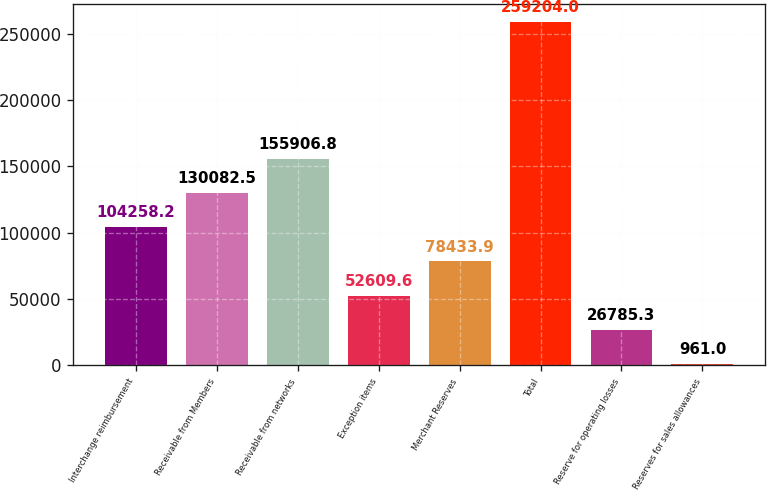<chart> <loc_0><loc_0><loc_500><loc_500><bar_chart><fcel>Interchange reimbursement<fcel>Receivable from Members<fcel>Receivable from networks<fcel>Exception items<fcel>Merchant Reserves<fcel>Total<fcel>Reserve for operating losses<fcel>Reserves for sales allowances<nl><fcel>104258<fcel>130082<fcel>155907<fcel>52609.6<fcel>78433.9<fcel>259204<fcel>26785.3<fcel>961<nl></chart> 